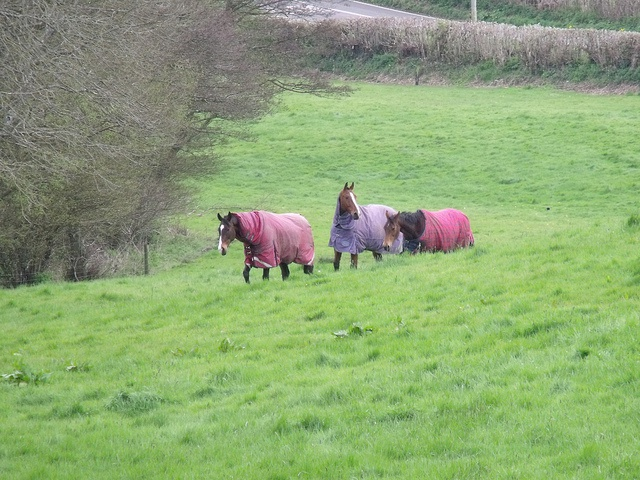Describe the objects in this image and their specific colors. I can see horse in gray, lightpink, brown, and black tones, horse in gray, brown, and violet tones, horse in gray, darkgray, and lavender tones, and horse in gray, darkgray, and lavender tones in this image. 